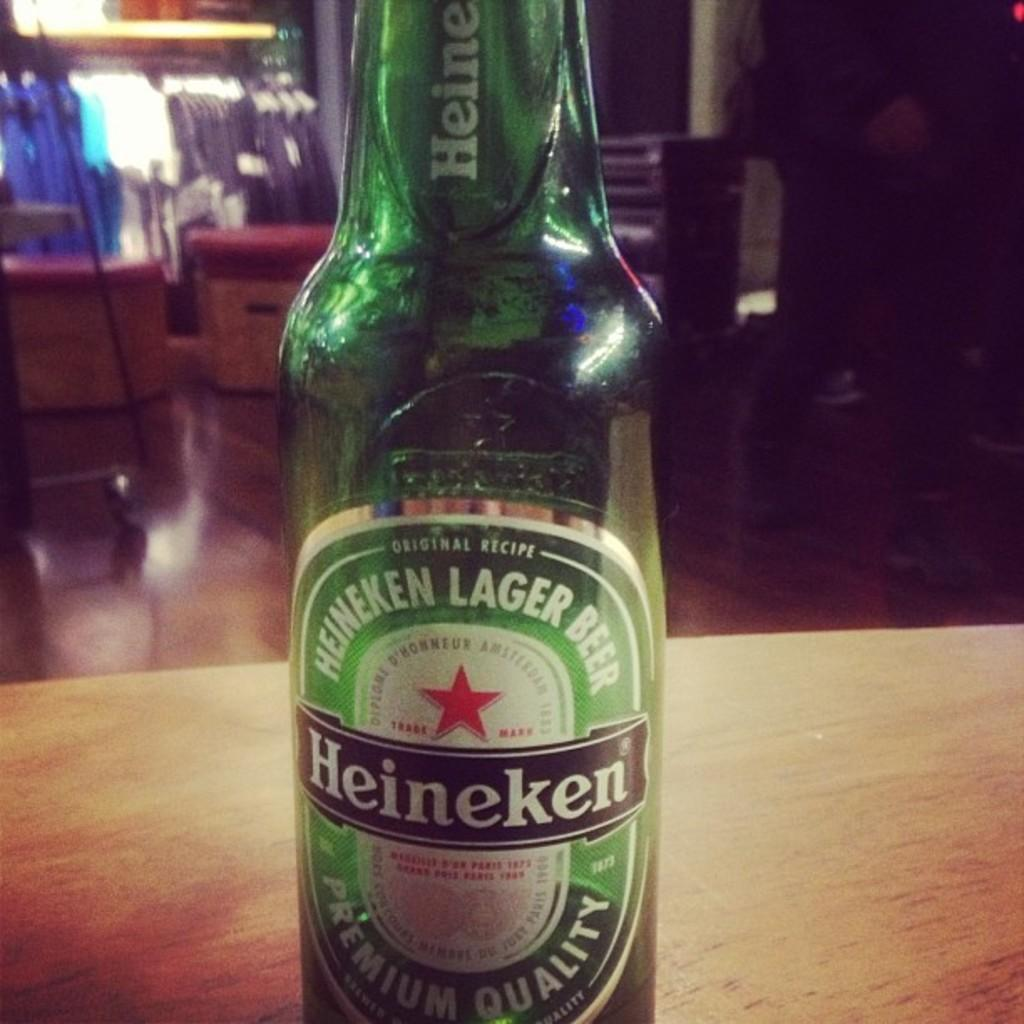Provide a one-sentence caption for the provided image. A GREEN BOTTLE OF PREMIUM QUALITY HEINEKEN LAGER BEER. 